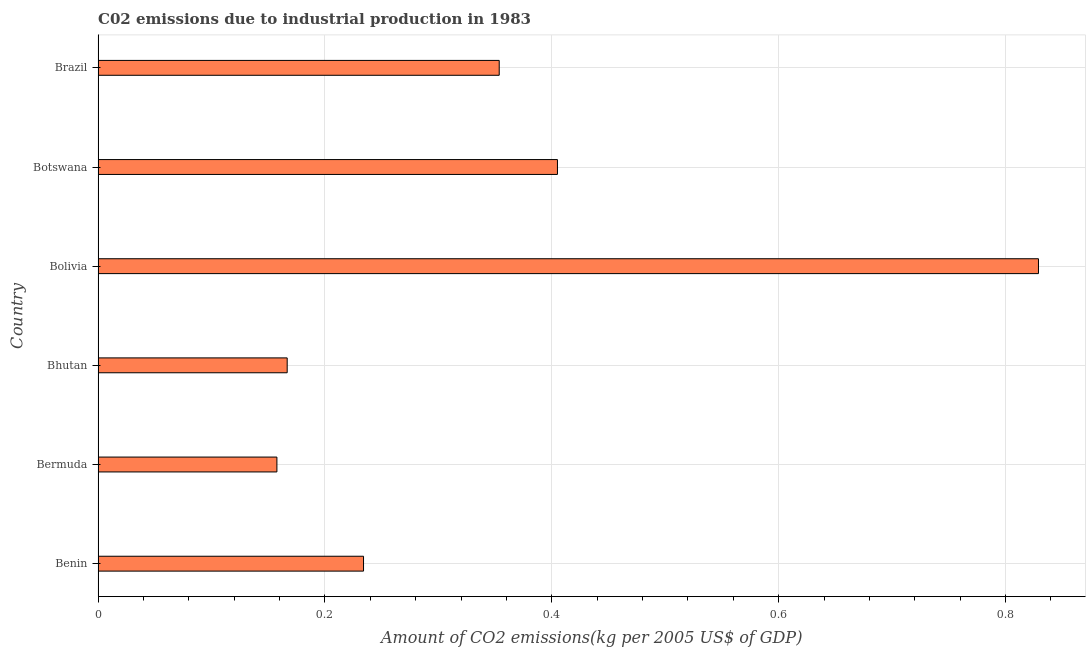What is the title of the graph?
Provide a succinct answer. C02 emissions due to industrial production in 1983. What is the label or title of the X-axis?
Your response must be concise. Amount of CO2 emissions(kg per 2005 US$ of GDP). What is the label or title of the Y-axis?
Offer a very short reply. Country. What is the amount of co2 emissions in Bhutan?
Keep it short and to the point. 0.17. Across all countries, what is the maximum amount of co2 emissions?
Offer a very short reply. 0.83. Across all countries, what is the minimum amount of co2 emissions?
Offer a terse response. 0.16. In which country was the amount of co2 emissions maximum?
Give a very brief answer. Bolivia. In which country was the amount of co2 emissions minimum?
Give a very brief answer. Bermuda. What is the sum of the amount of co2 emissions?
Your answer should be compact. 2.15. What is the difference between the amount of co2 emissions in Benin and Bolivia?
Offer a very short reply. -0.59. What is the average amount of co2 emissions per country?
Provide a succinct answer. 0.36. What is the median amount of co2 emissions?
Provide a succinct answer. 0.29. In how many countries, is the amount of co2 emissions greater than 0.48 kg per 2005 US$ of GDP?
Your answer should be compact. 1. What is the ratio of the amount of co2 emissions in Bolivia to that in Botswana?
Give a very brief answer. 2.05. Is the difference between the amount of co2 emissions in Benin and Bermuda greater than the difference between any two countries?
Your response must be concise. No. What is the difference between the highest and the second highest amount of co2 emissions?
Your answer should be compact. 0.42. Is the sum of the amount of co2 emissions in Bhutan and Bolivia greater than the maximum amount of co2 emissions across all countries?
Ensure brevity in your answer.  Yes. What is the difference between the highest and the lowest amount of co2 emissions?
Your answer should be very brief. 0.67. In how many countries, is the amount of co2 emissions greater than the average amount of co2 emissions taken over all countries?
Provide a short and direct response. 2. Are all the bars in the graph horizontal?
Ensure brevity in your answer.  Yes. How many countries are there in the graph?
Offer a very short reply. 6. What is the difference between two consecutive major ticks on the X-axis?
Your answer should be compact. 0.2. Are the values on the major ticks of X-axis written in scientific E-notation?
Ensure brevity in your answer.  No. What is the Amount of CO2 emissions(kg per 2005 US$ of GDP) in Benin?
Offer a very short reply. 0.23. What is the Amount of CO2 emissions(kg per 2005 US$ of GDP) in Bermuda?
Provide a short and direct response. 0.16. What is the Amount of CO2 emissions(kg per 2005 US$ of GDP) of Bhutan?
Ensure brevity in your answer.  0.17. What is the Amount of CO2 emissions(kg per 2005 US$ of GDP) in Bolivia?
Keep it short and to the point. 0.83. What is the Amount of CO2 emissions(kg per 2005 US$ of GDP) in Botswana?
Your answer should be very brief. 0.41. What is the Amount of CO2 emissions(kg per 2005 US$ of GDP) in Brazil?
Make the answer very short. 0.35. What is the difference between the Amount of CO2 emissions(kg per 2005 US$ of GDP) in Benin and Bermuda?
Ensure brevity in your answer.  0.08. What is the difference between the Amount of CO2 emissions(kg per 2005 US$ of GDP) in Benin and Bhutan?
Your answer should be very brief. 0.07. What is the difference between the Amount of CO2 emissions(kg per 2005 US$ of GDP) in Benin and Bolivia?
Your response must be concise. -0.6. What is the difference between the Amount of CO2 emissions(kg per 2005 US$ of GDP) in Benin and Botswana?
Offer a very short reply. -0.17. What is the difference between the Amount of CO2 emissions(kg per 2005 US$ of GDP) in Benin and Brazil?
Make the answer very short. -0.12. What is the difference between the Amount of CO2 emissions(kg per 2005 US$ of GDP) in Bermuda and Bhutan?
Provide a succinct answer. -0.01. What is the difference between the Amount of CO2 emissions(kg per 2005 US$ of GDP) in Bermuda and Bolivia?
Your response must be concise. -0.67. What is the difference between the Amount of CO2 emissions(kg per 2005 US$ of GDP) in Bermuda and Botswana?
Offer a terse response. -0.25. What is the difference between the Amount of CO2 emissions(kg per 2005 US$ of GDP) in Bermuda and Brazil?
Your answer should be compact. -0.2. What is the difference between the Amount of CO2 emissions(kg per 2005 US$ of GDP) in Bhutan and Bolivia?
Give a very brief answer. -0.66. What is the difference between the Amount of CO2 emissions(kg per 2005 US$ of GDP) in Bhutan and Botswana?
Offer a very short reply. -0.24. What is the difference between the Amount of CO2 emissions(kg per 2005 US$ of GDP) in Bhutan and Brazil?
Offer a terse response. -0.19. What is the difference between the Amount of CO2 emissions(kg per 2005 US$ of GDP) in Bolivia and Botswana?
Provide a short and direct response. 0.42. What is the difference between the Amount of CO2 emissions(kg per 2005 US$ of GDP) in Bolivia and Brazil?
Keep it short and to the point. 0.48. What is the difference between the Amount of CO2 emissions(kg per 2005 US$ of GDP) in Botswana and Brazil?
Ensure brevity in your answer.  0.05. What is the ratio of the Amount of CO2 emissions(kg per 2005 US$ of GDP) in Benin to that in Bermuda?
Make the answer very short. 1.48. What is the ratio of the Amount of CO2 emissions(kg per 2005 US$ of GDP) in Benin to that in Bhutan?
Offer a terse response. 1.4. What is the ratio of the Amount of CO2 emissions(kg per 2005 US$ of GDP) in Benin to that in Bolivia?
Your response must be concise. 0.28. What is the ratio of the Amount of CO2 emissions(kg per 2005 US$ of GDP) in Benin to that in Botswana?
Your response must be concise. 0.58. What is the ratio of the Amount of CO2 emissions(kg per 2005 US$ of GDP) in Benin to that in Brazil?
Your answer should be very brief. 0.66. What is the ratio of the Amount of CO2 emissions(kg per 2005 US$ of GDP) in Bermuda to that in Bhutan?
Provide a short and direct response. 0.95. What is the ratio of the Amount of CO2 emissions(kg per 2005 US$ of GDP) in Bermuda to that in Bolivia?
Offer a terse response. 0.19. What is the ratio of the Amount of CO2 emissions(kg per 2005 US$ of GDP) in Bermuda to that in Botswana?
Your answer should be very brief. 0.39. What is the ratio of the Amount of CO2 emissions(kg per 2005 US$ of GDP) in Bermuda to that in Brazil?
Your answer should be compact. 0.45. What is the ratio of the Amount of CO2 emissions(kg per 2005 US$ of GDP) in Bhutan to that in Bolivia?
Your answer should be very brief. 0.2. What is the ratio of the Amount of CO2 emissions(kg per 2005 US$ of GDP) in Bhutan to that in Botswana?
Offer a terse response. 0.41. What is the ratio of the Amount of CO2 emissions(kg per 2005 US$ of GDP) in Bhutan to that in Brazil?
Ensure brevity in your answer.  0.47. What is the ratio of the Amount of CO2 emissions(kg per 2005 US$ of GDP) in Bolivia to that in Botswana?
Provide a succinct answer. 2.05. What is the ratio of the Amount of CO2 emissions(kg per 2005 US$ of GDP) in Bolivia to that in Brazil?
Your answer should be very brief. 2.34. What is the ratio of the Amount of CO2 emissions(kg per 2005 US$ of GDP) in Botswana to that in Brazil?
Provide a short and direct response. 1.15. 